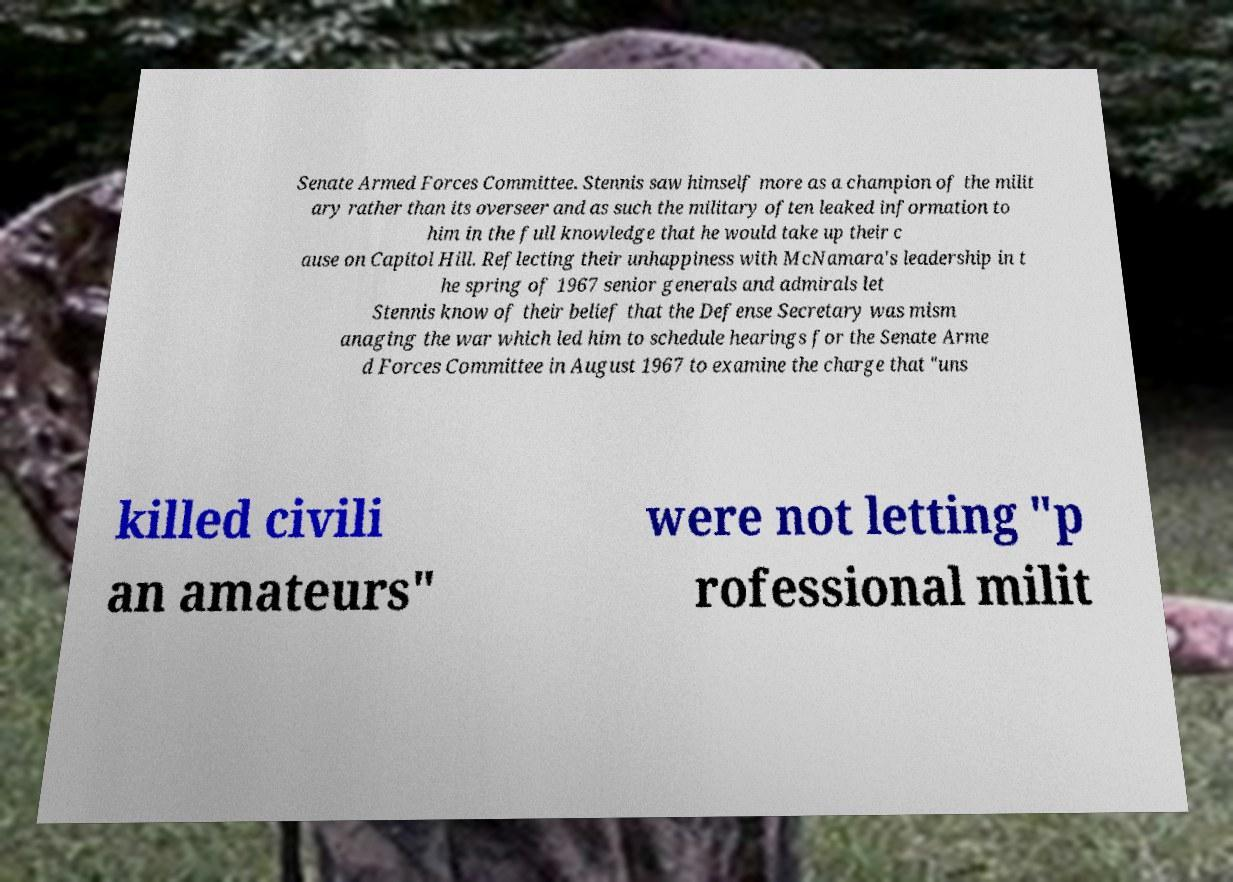Can you accurately transcribe the text from the provided image for me? Senate Armed Forces Committee. Stennis saw himself more as a champion of the milit ary rather than its overseer and as such the military often leaked information to him in the full knowledge that he would take up their c ause on Capitol Hill. Reflecting their unhappiness with McNamara's leadership in t he spring of 1967 senior generals and admirals let Stennis know of their belief that the Defense Secretary was mism anaging the war which led him to schedule hearings for the Senate Arme d Forces Committee in August 1967 to examine the charge that "uns killed civili an amateurs" were not letting "p rofessional milit 